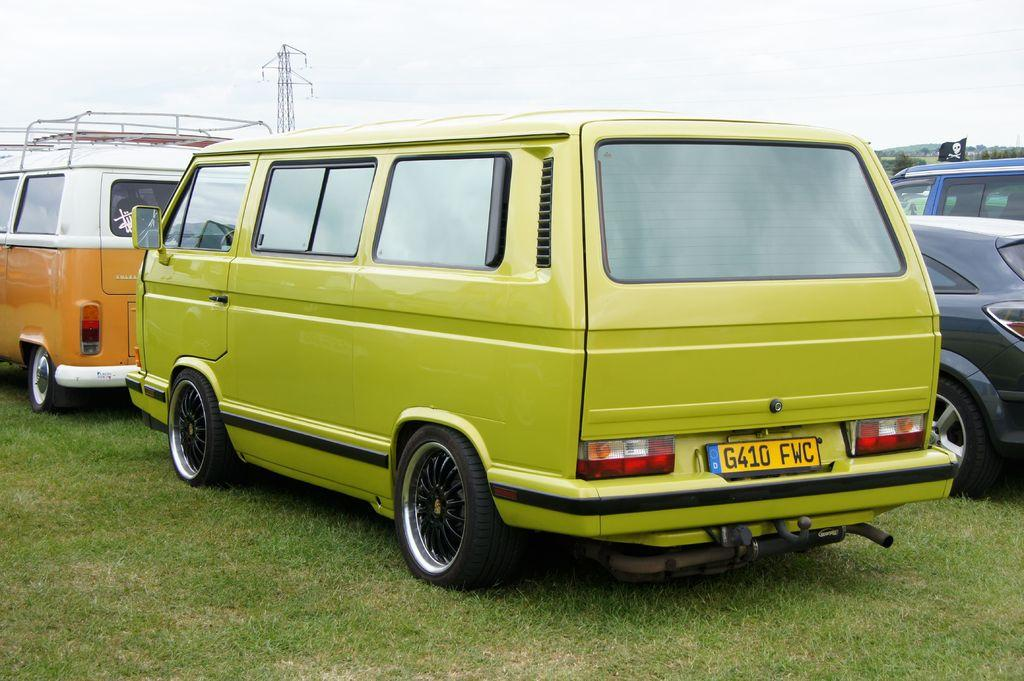Provide a one-sentence caption for the provided image. a green VW bus has a yellow license plate saying G410 FWC is sitting behind an orange bus. 